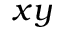<formula> <loc_0><loc_0><loc_500><loc_500>x y</formula> 